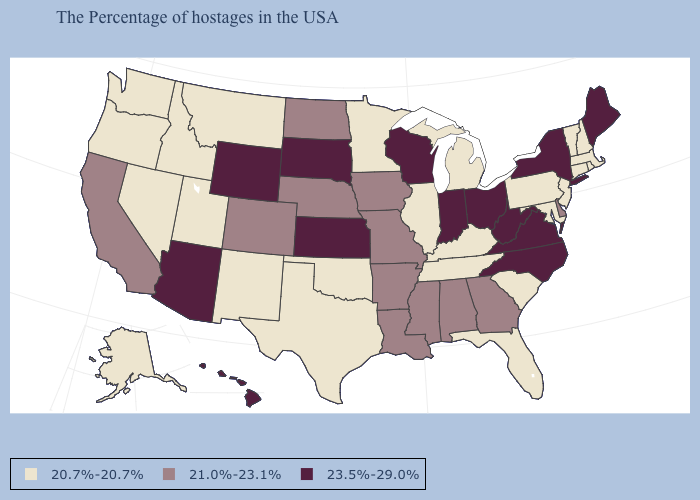Name the states that have a value in the range 20.7%-20.7%?
Answer briefly. Massachusetts, Rhode Island, New Hampshire, Vermont, Connecticut, New Jersey, Maryland, Pennsylvania, South Carolina, Florida, Michigan, Kentucky, Tennessee, Illinois, Minnesota, Oklahoma, Texas, New Mexico, Utah, Montana, Idaho, Nevada, Washington, Oregon, Alaska. Does New Mexico have the lowest value in the USA?
Short answer required. Yes. How many symbols are there in the legend?
Answer briefly. 3. Name the states that have a value in the range 21.0%-23.1%?
Quick response, please. Delaware, Georgia, Alabama, Mississippi, Louisiana, Missouri, Arkansas, Iowa, Nebraska, North Dakota, Colorado, California. Which states hav the highest value in the South?
Keep it brief. Virginia, North Carolina, West Virginia. Name the states that have a value in the range 23.5%-29.0%?
Concise answer only. Maine, New York, Virginia, North Carolina, West Virginia, Ohio, Indiana, Wisconsin, Kansas, South Dakota, Wyoming, Arizona, Hawaii. Does Nevada have the highest value in the USA?
Keep it brief. No. Among the states that border Texas , does Oklahoma have the lowest value?
Concise answer only. Yes. Among the states that border Missouri , which have the lowest value?
Be succinct. Kentucky, Tennessee, Illinois, Oklahoma. Which states have the highest value in the USA?
Answer briefly. Maine, New York, Virginia, North Carolina, West Virginia, Ohio, Indiana, Wisconsin, Kansas, South Dakota, Wyoming, Arizona, Hawaii. Name the states that have a value in the range 23.5%-29.0%?
Be succinct. Maine, New York, Virginia, North Carolina, West Virginia, Ohio, Indiana, Wisconsin, Kansas, South Dakota, Wyoming, Arizona, Hawaii. What is the lowest value in the West?
Short answer required. 20.7%-20.7%. Does New Hampshire have the lowest value in the USA?
Concise answer only. Yes. Among the states that border Colorado , does Oklahoma have the highest value?
Keep it brief. No. Does Rhode Island have a higher value than Pennsylvania?
Quick response, please. No. 